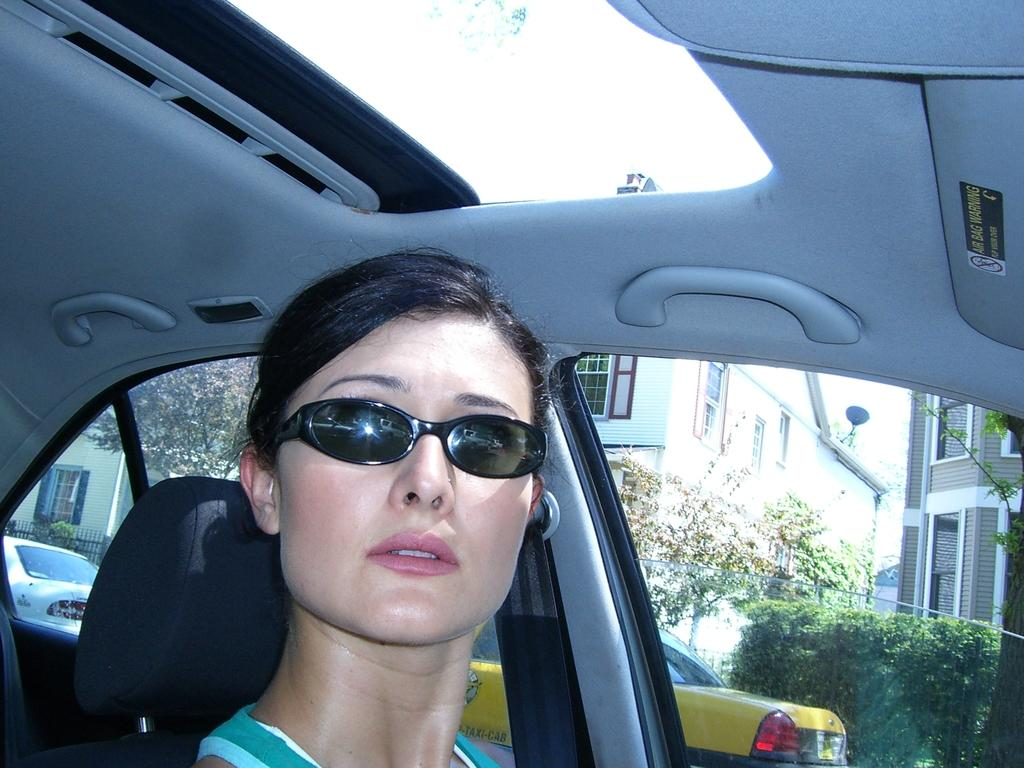What is the lady in the image wearing on her face? The lady is wearing goggles in the image. Where is the lady sitting in the image? The lady is sitting inside a car. What feature does the car have that allows the lady to enter and exit? The car has an opening. What can be seen outside the car in the image? Other vehicles, buildings, trees, and bushes are visible outside the car. What type of church is visible in the image? There is no church present in the image; it features a lady sitting in a car with other vehicles, buildings, trees, and bushes visible outside. 